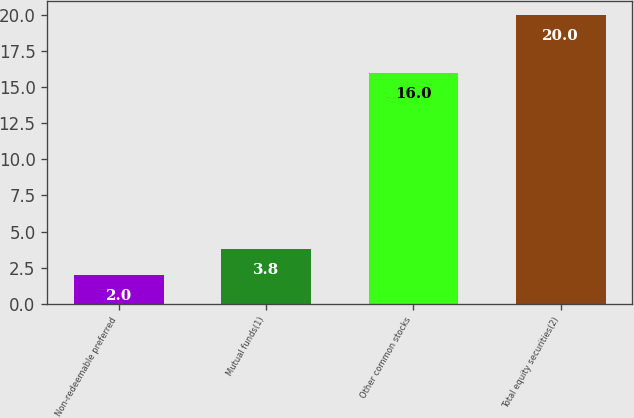<chart> <loc_0><loc_0><loc_500><loc_500><bar_chart><fcel>Non-redeemable preferred<fcel>Mutual funds(1)<fcel>Other common stocks<fcel>Total equity securities(2)<nl><fcel>2<fcel>3.8<fcel>16<fcel>20<nl></chart> 